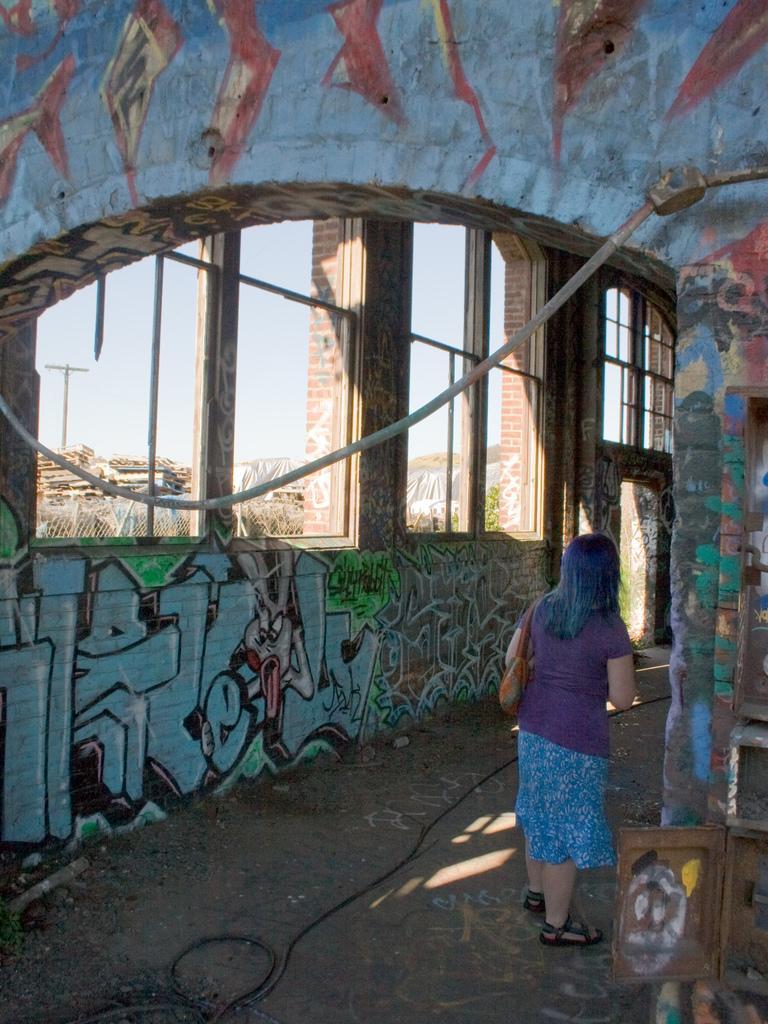Can you describe this image briefly? In this image we can see inside of a building. There are walls with paintings. Also there are windows. And we can see a lady. On the floor there is wire. Through the windows we can see sky. 